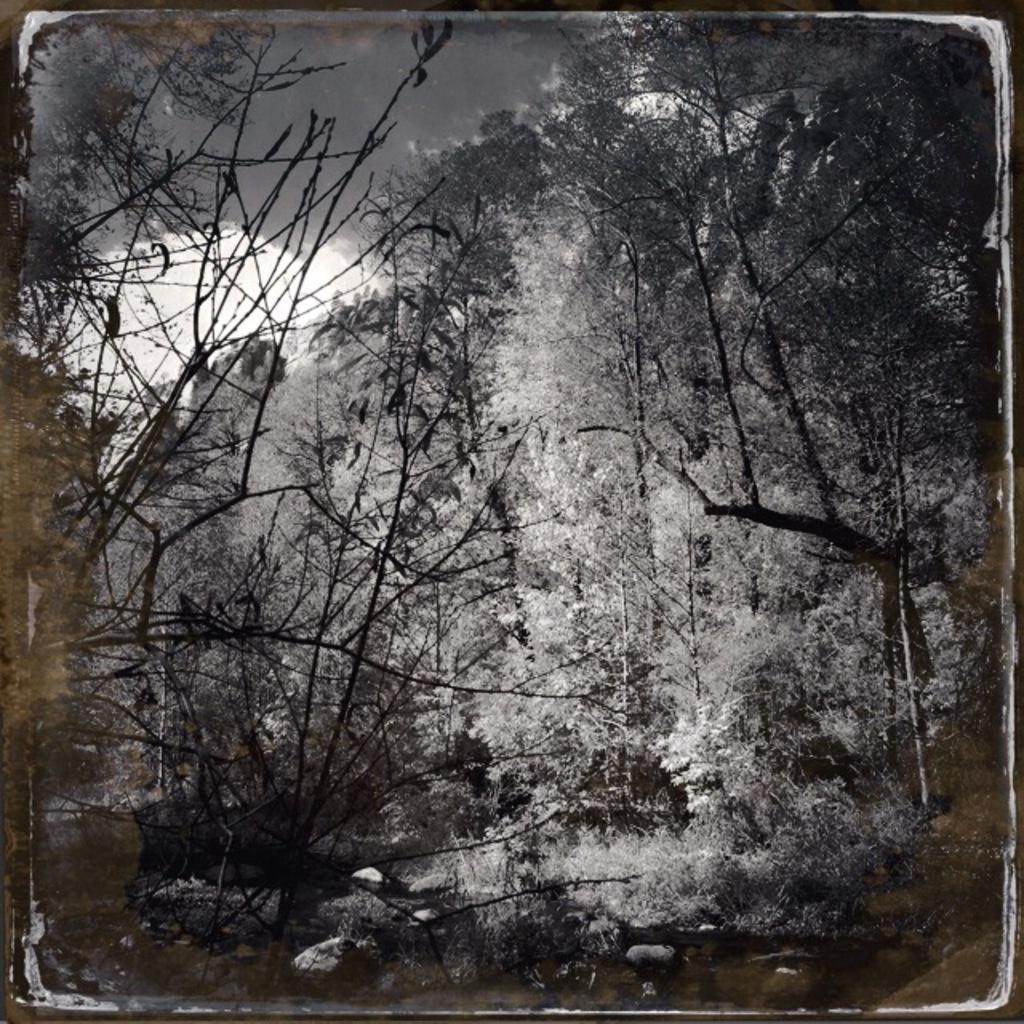Could you give a brief overview of what you see in this image? This is black and white picture where we can see trees and plants. Top of the image cloud is there. 